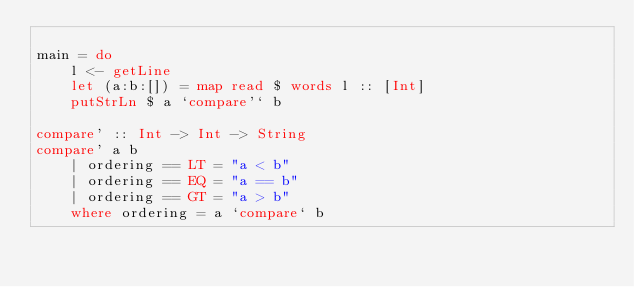Convert code to text. <code><loc_0><loc_0><loc_500><loc_500><_Haskell_>
main = do
    l <- getLine
    let (a:b:[]) = map read $ words l :: [Int]
    putStrLn $ a `compare'` b

compare' :: Int -> Int -> String
compare' a b
    | ordering == LT = "a < b"
    | ordering == EQ = "a == b"
    | ordering == GT = "a > b"
    where ordering = a `compare` b
</code> 